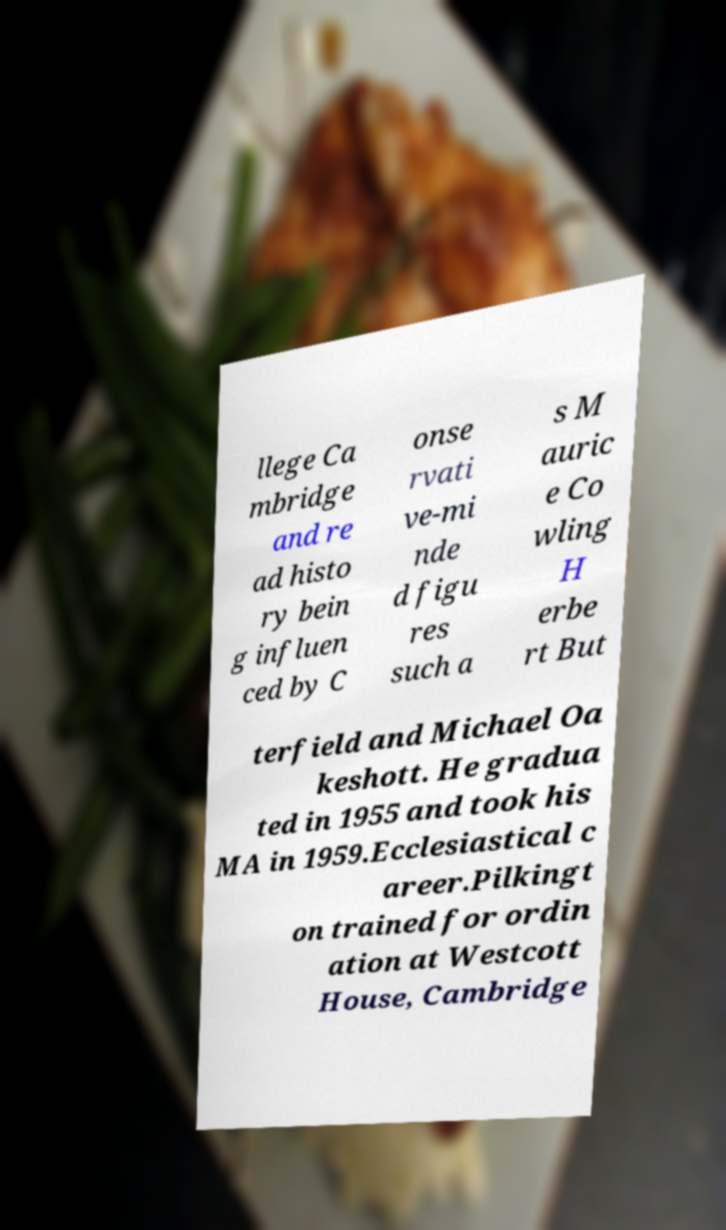Can you read and provide the text displayed in the image?This photo seems to have some interesting text. Can you extract and type it out for me? llege Ca mbridge and re ad histo ry bein g influen ced by C onse rvati ve-mi nde d figu res such a s M auric e Co wling H erbe rt But terfield and Michael Oa keshott. He gradua ted in 1955 and took his MA in 1959.Ecclesiastical c areer.Pilkingt on trained for ordin ation at Westcott House, Cambridge 